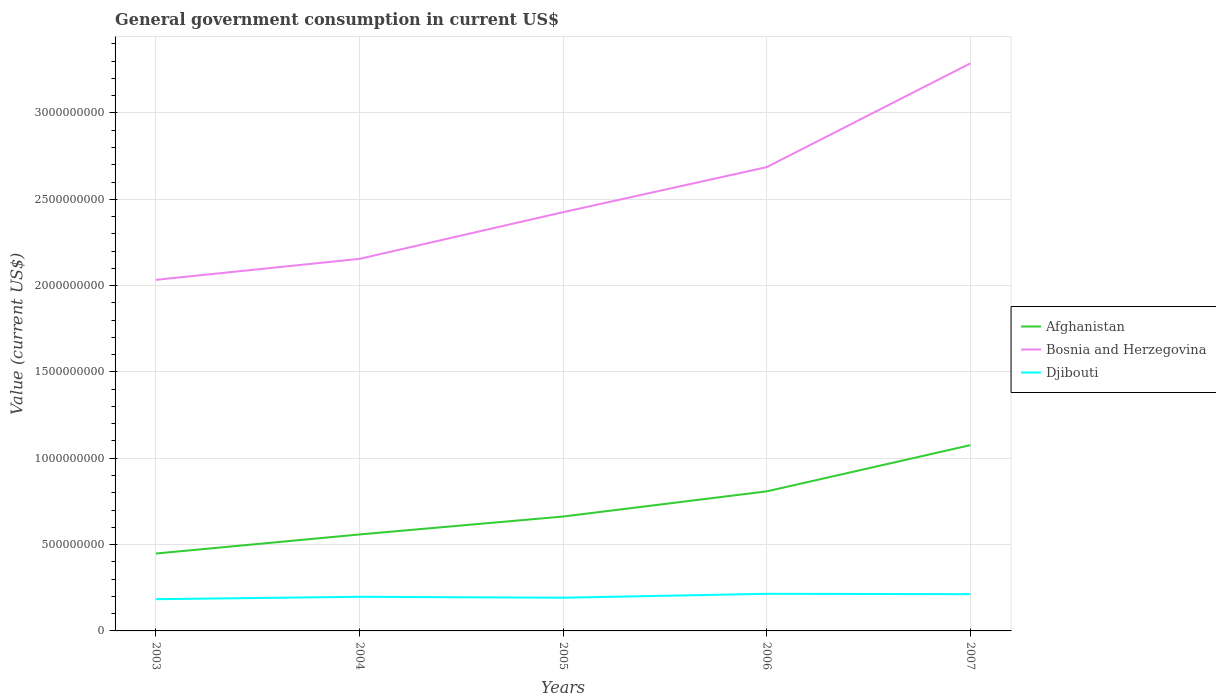How many different coloured lines are there?
Give a very brief answer. 3. Is the number of lines equal to the number of legend labels?
Ensure brevity in your answer.  Yes. Across all years, what is the maximum government conusmption in Djibouti?
Your response must be concise. 1.84e+08. What is the total government conusmption in Djibouti in the graph?
Offer a very short reply. 5.58e+06. What is the difference between the highest and the second highest government conusmption in Bosnia and Herzegovina?
Ensure brevity in your answer.  1.25e+09. How many lines are there?
Offer a very short reply. 3. How many years are there in the graph?
Your response must be concise. 5. What is the difference between two consecutive major ticks on the Y-axis?
Your answer should be very brief. 5.00e+08. Does the graph contain any zero values?
Provide a succinct answer. No. Does the graph contain grids?
Offer a very short reply. Yes. Where does the legend appear in the graph?
Your response must be concise. Center right. How many legend labels are there?
Ensure brevity in your answer.  3. How are the legend labels stacked?
Provide a succinct answer. Vertical. What is the title of the graph?
Provide a succinct answer. General government consumption in current US$. What is the label or title of the Y-axis?
Offer a very short reply. Value (current US$). What is the Value (current US$) of Afghanistan in 2003?
Provide a short and direct response. 4.48e+08. What is the Value (current US$) in Bosnia and Herzegovina in 2003?
Make the answer very short. 2.03e+09. What is the Value (current US$) of Djibouti in 2003?
Offer a very short reply. 1.84e+08. What is the Value (current US$) in Afghanistan in 2004?
Make the answer very short. 5.59e+08. What is the Value (current US$) of Bosnia and Herzegovina in 2004?
Give a very brief answer. 2.15e+09. What is the Value (current US$) of Djibouti in 2004?
Offer a terse response. 1.98e+08. What is the Value (current US$) in Afghanistan in 2005?
Ensure brevity in your answer.  6.63e+08. What is the Value (current US$) of Bosnia and Herzegovina in 2005?
Provide a short and direct response. 2.43e+09. What is the Value (current US$) in Djibouti in 2005?
Keep it short and to the point. 1.92e+08. What is the Value (current US$) of Afghanistan in 2006?
Ensure brevity in your answer.  8.08e+08. What is the Value (current US$) of Bosnia and Herzegovina in 2006?
Give a very brief answer. 2.69e+09. What is the Value (current US$) of Djibouti in 2006?
Keep it short and to the point. 2.15e+08. What is the Value (current US$) in Afghanistan in 2007?
Provide a short and direct response. 1.08e+09. What is the Value (current US$) in Bosnia and Herzegovina in 2007?
Make the answer very short. 3.29e+09. What is the Value (current US$) in Djibouti in 2007?
Your answer should be compact. 2.13e+08. Across all years, what is the maximum Value (current US$) of Afghanistan?
Provide a succinct answer. 1.08e+09. Across all years, what is the maximum Value (current US$) in Bosnia and Herzegovina?
Ensure brevity in your answer.  3.29e+09. Across all years, what is the maximum Value (current US$) of Djibouti?
Offer a very short reply. 2.15e+08. Across all years, what is the minimum Value (current US$) of Afghanistan?
Keep it short and to the point. 4.48e+08. Across all years, what is the minimum Value (current US$) of Bosnia and Herzegovina?
Provide a short and direct response. 2.03e+09. Across all years, what is the minimum Value (current US$) in Djibouti?
Offer a terse response. 1.84e+08. What is the total Value (current US$) of Afghanistan in the graph?
Your answer should be compact. 3.55e+09. What is the total Value (current US$) of Bosnia and Herzegovina in the graph?
Ensure brevity in your answer.  1.26e+1. What is the total Value (current US$) of Djibouti in the graph?
Give a very brief answer. 1.00e+09. What is the difference between the Value (current US$) of Afghanistan in 2003 and that in 2004?
Offer a terse response. -1.10e+08. What is the difference between the Value (current US$) in Bosnia and Herzegovina in 2003 and that in 2004?
Offer a very short reply. -1.21e+08. What is the difference between the Value (current US$) of Djibouti in 2003 and that in 2004?
Keep it short and to the point. -1.40e+07. What is the difference between the Value (current US$) of Afghanistan in 2003 and that in 2005?
Your response must be concise. -2.14e+08. What is the difference between the Value (current US$) in Bosnia and Herzegovina in 2003 and that in 2005?
Give a very brief answer. -3.92e+08. What is the difference between the Value (current US$) of Djibouti in 2003 and that in 2005?
Your answer should be compact. -8.39e+06. What is the difference between the Value (current US$) of Afghanistan in 2003 and that in 2006?
Your answer should be compact. -3.60e+08. What is the difference between the Value (current US$) in Bosnia and Herzegovina in 2003 and that in 2006?
Offer a terse response. -6.53e+08. What is the difference between the Value (current US$) in Djibouti in 2003 and that in 2006?
Offer a terse response. -3.12e+07. What is the difference between the Value (current US$) in Afghanistan in 2003 and that in 2007?
Your answer should be very brief. -6.28e+08. What is the difference between the Value (current US$) in Bosnia and Herzegovina in 2003 and that in 2007?
Keep it short and to the point. -1.25e+09. What is the difference between the Value (current US$) of Djibouti in 2003 and that in 2007?
Offer a terse response. -2.92e+07. What is the difference between the Value (current US$) of Afghanistan in 2004 and that in 2005?
Offer a very short reply. -1.04e+08. What is the difference between the Value (current US$) in Bosnia and Herzegovina in 2004 and that in 2005?
Your answer should be very brief. -2.70e+08. What is the difference between the Value (current US$) of Djibouti in 2004 and that in 2005?
Offer a very short reply. 5.58e+06. What is the difference between the Value (current US$) in Afghanistan in 2004 and that in 2006?
Offer a terse response. -2.50e+08. What is the difference between the Value (current US$) in Bosnia and Herzegovina in 2004 and that in 2006?
Your answer should be compact. -5.31e+08. What is the difference between the Value (current US$) of Djibouti in 2004 and that in 2006?
Ensure brevity in your answer.  -1.72e+07. What is the difference between the Value (current US$) of Afghanistan in 2004 and that in 2007?
Keep it short and to the point. -5.17e+08. What is the difference between the Value (current US$) in Bosnia and Herzegovina in 2004 and that in 2007?
Ensure brevity in your answer.  -1.13e+09. What is the difference between the Value (current US$) in Djibouti in 2004 and that in 2007?
Make the answer very short. -1.52e+07. What is the difference between the Value (current US$) in Afghanistan in 2005 and that in 2006?
Make the answer very short. -1.46e+08. What is the difference between the Value (current US$) of Bosnia and Herzegovina in 2005 and that in 2006?
Keep it short and to the point. -2.61e+08. What is the difference between the Value (current US$) in Djibouti in 2005 and that in 2006?
Offer a terse response. -2.28e+07. What is the difference between the Value (current US$) in Afghanistan in 2005 and that in 2007?
Provide a succinct answer. -4.13e+08. What is the difference between the Value (current US$) in Bosnia and Herzegovina in 2005 and that in 2007?
Make the answer very short. -8.62e+08. What is the difference between the Value (current US$) in Djibouti in 2005 and that in 2007?
Keep it short and to the point. -2.08e+07. What is the difference between the Value (current US$) of Afghanistan in 2006 and that in 2007?
Offer a very short reply. -2.68e+08. What is the difference between the Value (current US$) of Bosnia and Herzegovina in 2006 and that in 2007?
Your response must be concise. -6.01e+08. What is the difference between the Value (current US$) of Djibouti in 2006 and that in 2007?
Provide a succinct answer. 2.01e+06. What is the difference between the Value (current US$) of Afghanistan in 2003 and the Value (current US$) of Bosnia and Herzegovina in 2004?
Keep it short and to the point. -1.71e+09. What is the difference between the Value (current US$) of Afghanistan in 2003 and the Value (current US$) of Djibouti in 2004?
Keep it short and to the point. 2.50e+08. What is the difference between the Value (current US$) in Bosnia and Herzegovina in 2003 and the Value (current US$) in Djibouti in 2004?
Ensure brevity in your answer.  1.84e+09. What is the difference between the Value (current US$) in Afghanistan in 2003 and the Value (current US$) in Bosnia and Herzegovina in 2005?
Ensure brevity in your answer.  -1.98e+09. What is the difference between the Value (current US$) in Afghanistan in 2003 and the Value (current US$) in Djibouti in 2005?
Give a very brief answer. 2.56e+08. What is the difference between the Value (current US$) of Bosnia and Herzegovina in 2003 and the Value (current US$) of Djibouti in 2005?
Give a very brief answer. 1.84e+09. What is the difference between the Value (current US$) in Afghanistan in 2003 and the Value (current US$) in Bosnia and Herzegovina in 2006?
Provide a short and direct response. -2.24e+09. What is the difference between the Value (current US$) of Afghanistan in 2003 and the Value (current US$) of Djibouti in 2006?
Make the answer very short. 2.33e+08. What is the difference between the Value (current US$) of Bosnia and Herzegovina in 2003 and the Value (current US$) of Djibouti in 2006?
Provide a succinct answer. 1.82e+09. What is the difference between the Value (current US$) of Afghanistan in 2003 and the Value (current US$) of Bosnia and Herzegovina in 2007?
Provide a succinct answer. -2.84e+09. What is the difference between the Value (current US$) in Afghanistan in 2003 and the Value (current US$) in Djibouti in 2007?
Offer a terse response. 2.35e+08. What is the difference between the Value (current US$) of Bosnia and Herzegovina in 2003 and the Value (current US$) of Djibouti in 2007?
Keep it short and to the point. 1.82e+09. What is the difference between the Value (current US$) of Afghanistan in 2004 and the Value (current US$) of Bosnia and Herzegovina in 2005?
Your answer should be compact. -1.87e+09. What is the difference between the Value (current US$) in Afghanistan in 2004 and the Value (current US$) in Djibouti in 2005?
Provide a short and direct response. 3.67e+08. What is the difference between the Value (current US$) of Bosnia and Herzegovina in 2004 and the Value (current US$) of Djibouti in 2005?
Provide a succinct answer. 1.96e+09. What is the difference between the Value (current US$) in Afghanistan in 2004 and the Value (current US$) in Bosnia and Herzegovina in 2006?
Offer a very short reply. -2.13e+09. What is the difference between the Value (current US$) in Afghanistan in 2004 and the Value (current US$) in Djibouti in 2006?
Provide a succinct answer. 3.44e+08. What is the difference between the Value (current US$) of Bosnia and Herzegovina in 2004 and the Value (current US$) of Djibouti in 2006?
Ensure brevity in your answer.  1.94e+09. What is the difference between the Value (current US$) of Afghanistan in 2004 and the Value (current US$) of Bosnia and Herzegovina in 2007?
Your answer should be very brief. -2.73e+09. What is the difference between the Value (current US$) of Afghanistan in 2004 and the Value (current US$) of Djibouti in 2007?
Your answer should be very brief. 3.46e+08. What is the difference between the Value (current US$) in Bosnia and Herzegovina in 2004 and the Value (current US$) in Djibouti in 2007?
Keep it short and to the point. 1.94e+09. What is the difference between the Value (current US$) in Afghanistan in 2005 and the Value (current US$) in Bosnia and Herzegovina in 2006?
Your response must be concise. -2.02e+09. What is the difference between the Value (current US$) of Afghanistan in 2005 and the Value (current US$) of Djibouti in 2006?
Give a very brief answer. 4.48e+08. What is the difference between the Value (current US$) in Bosnia and Herzegovina in 2005 and the Value (current US$) in Djibouti in 2006?
Your answer should be compact. 2.21e+09. What is the difference between the Value (current US$) of Afghanistan in 2005 and the Value (current US$) of Bosnia and Herzegovina in 2007?
Give a very brief answer. -2.62e+09. What is the difference between the Value (current US$) of Afghanistan in 2005 and the Value (current US$) of Djibouti in 2007?
Make the answer very short. 4.50e+08. What is the difference between the Value (current US$) in Bosnia and Herzegovina in 2005 and the Value (current US$) in Djibouti in 2007?
Give a very brief answer. 2.21e+09. What is the difference between the Value (current US$) of Afghanistan in 2006 and the Value (current US$) of Bosnia and Herzegovina in 2007?
Your answer should be very brief. -2.48e+09. What is the difference between the Value (current US$) in Afghanistan in 2006 and the Value (current US$) in Djibouti in 2007?
Provide a succinct answer. 5.95e+08. What is the difference between the Value (current US$) of Bosnia and Herzegovina in 2006 and the Value (current US$) of Djibouti in 2007?
Ensure brevity in your answer.  2.47e+09. What is the average Value (current US$) of Afghanistan per year?
Make the answer very short. 7.11e+08. What is the average Value (current US$) of Bosnia and Herzegovina per year?
Make the answer very short. 2.52e+09. What is the average Value (current US$) of Djibouti per year?
Provide a short and direct response. 2.00e+08. In the year 2003, what is the difference between the Value (current US$) of Afghanistan and Value (current US$) of Bosnia and Herzegovina?
Your answer should be very brief. -1.59e+09. In the year 2003, what is the difference between the Value (current US$) of Afghanistan and Value (current US$) of Djibouti?
Your response must be concise. 2.64e+08. In the year 2003, what is the difference between the Value (current US$) in Bosnia and Herzegovina and Value (current US$) in Djibouti?
Ensure brevity in your answer.  1.85e+09. In the year 2004, what is the difference between the Value (current US$) of Afghanistan and Value (current US$) of Bosnia and Herzegovina?
Give a very brief answer. -1.60e+09. In the year 2004, what is the difference between the Value (current US$) of Afghanistan and Value (current US$) of Djibouti?
Keep it short and to the point. 3.61e+08. In the year 2004, what is the difference between the Value (current US$) of Bosnia and Herzegovina and Value (current US$) of Djibouti?
Offer a very short reply. 1.96e+09. In the year 2005, what is the difference between the Value (current US$) in Afghanistan and Value (current US$) in Bosnia and Herzegovina?
Your answer should be compact. -1.76e+09. In the year 2005, what is the difference between the Value (current US$) of Afghanistan and Value (current US$) of Djibouti?
Your response must be concise. 4.70e+08. In the year 2005, what is the difference between the Value (current US$) of Bosnia and Herzegovina and Value (current US$) of Djibouti?
Provide a short and direct response. 2.23e+09. In the year 2006, what is the difference between the Value (current US$) of Afghanistan and Value (current US$) of Bosnia and Herzegovina?
Provide a short and direct response. -1.88e+09. In the year 2006, what is the difference between the Value (current US$) of Afghanistan and Value (current US$) of Djibouti?
Make the answer very short. 5.93e+08. In the year 2006, what is the difference between the Value (current US$) in Bosnia and Herzegovina and Value (current US$) in Djibouti?
Your answer should be very brief. 2.47e+09. In the year 2007, what is the difference between the Value (current US$) of Afghanistan and Value (current US$) of Bosnia and Herzegovina?
Provide a short and direct response. -2.21e+09. In the year 2007, what is the difference between the Value (current US$) of Afghanistan and Value (current US$) of Djibouti?
Your answer should be very brief. 8.63e+08. In the year 2007, what is the difference between the Value (current US$) in Bosnia and Herzegovina and Value (current US$) in Djibouti?
Keep it short and to the point. 3.07e+09. What is the ratio of the Value (current US$) of Afghanistan in 2003 to that in 2004?
Your answer should be very brief. 0.8. What is the ratio of the Value (current US$) in Bosnia and Herzegovina in 2003 to that in 2004?
Give a very brief answer. 0.94. What is the ratio of the Value (current US$) in Djibouti in 2003 to that in 2004?
Give a very brief answer. 0.93. What is the ratio of the Value (current US$) in Afghanistan in 2003 to that in 2005?
Offer a very short reply. 0.68. What is the ratio of the Value (current US$) of Bosnia and Herzegovina in 2003 to that in 2005?
Your answer should be compact. 0.84. What is the ratio of the Value (current US$) in Djibouti in 2003 to that in 2005?
Keep it short and to the point. 0.96. What is the ratio of the Value (current US$) of Afghanistan in 2003 to that in 2006?
Ensure brevity in your answer.  0.55. What is the ratio of the Value (current US$) of Bosnia and Herzegovina in 2003 to that in 2006?
Ensure brevity in your answer.  0.76. What is the ratio of the Value (current US$) in Djibouti in 2003 to that in 2006?
Offer a very short reply. 0.85. What is the ratio of the Value (current US$) in Afghanistan in 2003 to that in 2007?
Your answer should be very brief. 0.42. What is the ratio of the Value (current US$) of Bosnia and Herzegovina in 2003 to that in 2007?
Make the answer very short. 0.62. What is the ratio of the Value (current US$) of Djibouti in 2003 to that in 2007?
Your answer should be very brief. 0.86. What is the ratio of the Value (current US$) in Afghanistan in 2004 to that in 2005?
Provide a short and direct response. 0.84. What is the ratio of the Value (current US$) in Bosnia and Herzegovina in 2004 to that in 2005?
Give a very brief answer. 0.89. What is the ratio of the Value (current US$) of Afghanistan in 2004 to that in 2006?
Provide a short and direct response. 0.69. What is the ratio of the Value (current US$) of Bosnia and Herzegovina in 2004 to that in 2006?
Offer a terse response. 0.8. What is the ratio of the Value (current US$) of Djibouti in 2004 to that in 2006?
Provide a short and direct response. 0.92. What is the ratio of the Value (current US$) in Afghanistan in 2004 to that in 2007?
Your answer should be very brief. 0.52. What is the ratio of the Value (current US$) in Bosnia and Herzegovina in 2004 to that in 2007?
Provide a short and direct response. 0.66. What is the ratio of the Value (current US$) of Djibouti in 2004 to that in 2007?
Provide a short and direct response. 0.93. What is the ratio of the Value (current US$) of Afghanistan in 2005 to that in 2006?
Your answer should be compact. 0.82. What is the ratio of the Value (current US$) of Bosnia and Herzegovina in 2005 to that in 2006?
Your answer should be very brief. 0.9. What is the ratio of the Value (current US$) in Djibouti in 2005 to that in 2006?
Give a very brief answer. 0.89. What is the ratio of the Value (current US$) of Afghanistan in 2005 to that in 2007?
Keep it short and to the point. 0.62. What is the ratio of the Value (current US$) in Bosnia and Herzegovina in 2005 to that in 2007?
Your answer should be very brief. 0.74. What is the ratio of the Value (current US$) of Djibouti in 2005 to that in 2007?
Ensure brevity in your answer.  0.9. What is the ratio of the Value (current US$) of Afghanistan in 2006 to that in 2007?
Ensure brevity in your answer.  0.75. What is the ratio of the Value (current US$) in Bosnia and Herzegovina in 2006 to that in 2007?
Make the answer very short. 0.82. What is the ratio of the Value (current US$) of Djibouti in 2006 to that in 2007?
Your answer should be very brief. 1.01. What is the difference between the highest and the second highest Value (current US$) in Afghanistan?
Offer a terse response. 2.68e+08. What is the difference between the highest and the second highest Value (current US$) in Bosnia and Herzegovina?
Your answer should be very brief. 6.01e+08. What is the difference between the highest and the second highest Value (current US$) in Djibouti?
Ensure brevity in your answer.  2.01e+06. What is the difference between the highest and the lowest Value (current US$) of Afghanistan?
Give a very brief answer. 6.28e+08. What is the difference between the highest and the lowest Value (current US$) of Bosnia and Herzegovina?
Keep it short and to the point. 1.25e+09. What is the difference between the highest and the lowest Value (current US$) in Djibouti?
Your response must be concise. 3.12e+07. 